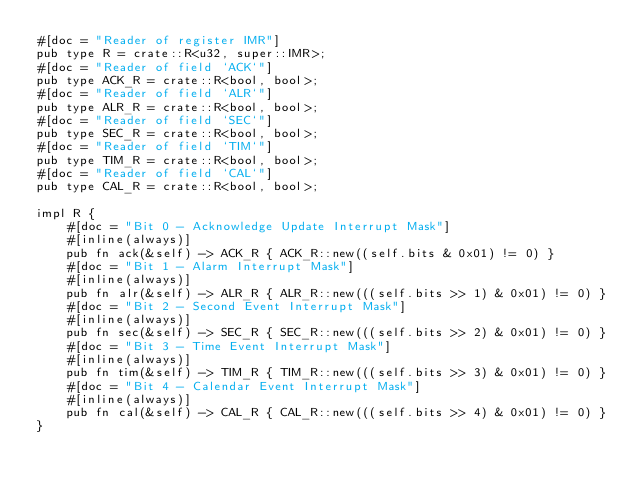<code> <loc_0><loc_0><loc_500><loc_500><_Rust_>#[doc = "Reader of register IMR"]
pub type R = crate::R<u32, super::IMR>;
#[doc = "Reader of field `ACK`"]
pub type ACK_R = crate::R<bool, bool>;
#[doc = "Reader of field `ALR`"]
pub type ALR_R = crate::R<bool, bool>;
#[doc = "Reader of field `SEC`"]
pub type SEC_R = crate::R<bool, bool>;
#[doc = "Reader of field `TIM`"]
pub type TIM_R = crate::R<bool, bool>;
#[doc = "Reader of field `CAL`"]
pub type CAL_R = crate::R<bool, bool>;

impl R {
    #[doc = "Bit 0 - Acknowledge Update Interrupt Mask"]
    #[inline(always)]
    pub fn ack(&self) -> ACK_R { ACK_R::new((self.bits & 0x01) != 0) }
    #[doc = "Bit 1 - Alarm Interrupt Mask"]
    #[inline(always)]
    pub fn alr(&self) -> ALR_R { ALR_R::new(((self.bits >> 1) & 0x01) != 0) }
    #[doc = "Bit 2 - Second Event Interrupt Mask"]
    #[inline(always)]
    pub fn sec(&self) -> SEC_R { SEC_R::new(((self.bits >> 2) & 0x01) != 0) }
    #[doc = "Bit 3 - Time Event Interrupt Mask"]
    #[inline(always)]
    pub fn tim(&self) -> TIM_R { TIM_R::new(((self.bits >> 3) & 0x01) != 0) }
    #[doc = "Bit 4 - Calendar Event Interrupt Mask"]
    #[inline(always)]
    pub fn cal(&self) -> CAL_R { CAL_R::new(((self.bits >> 4) & 0x01) != 0) }
}</code> 